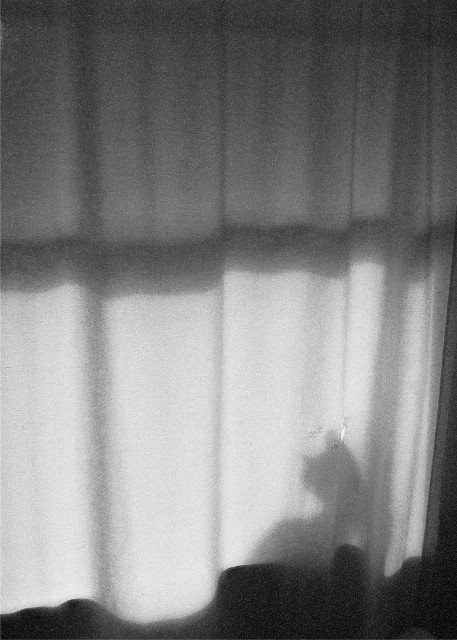Are there any color inconsistencies? The image is in black and white, showing a shadow of a figure against a curtain. There are varying shades of gray that portray the light source and shadows accurately, without any color inconsistencies since it lacks color variations beyond grayscale. 